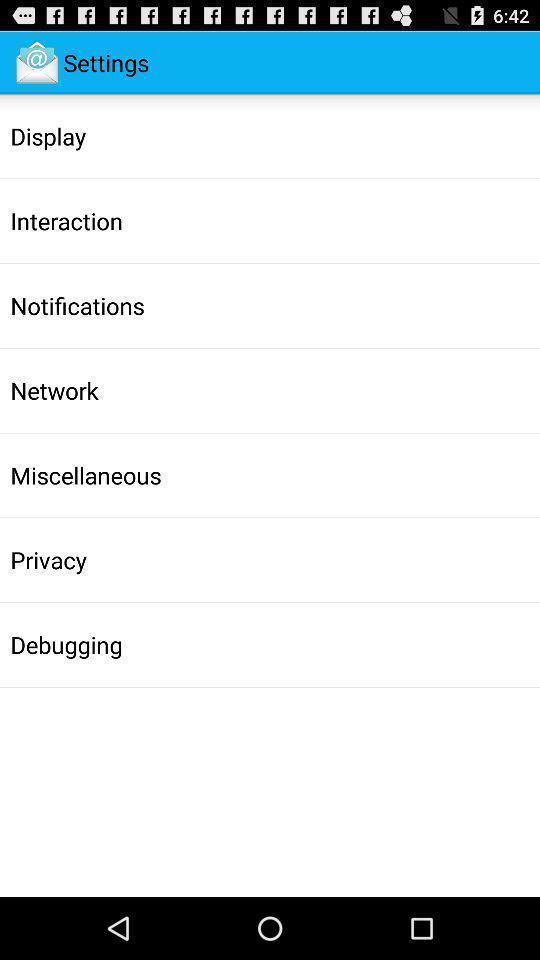Describe the visual elements of this screenshot. Settings page of a email management app is displaying. 